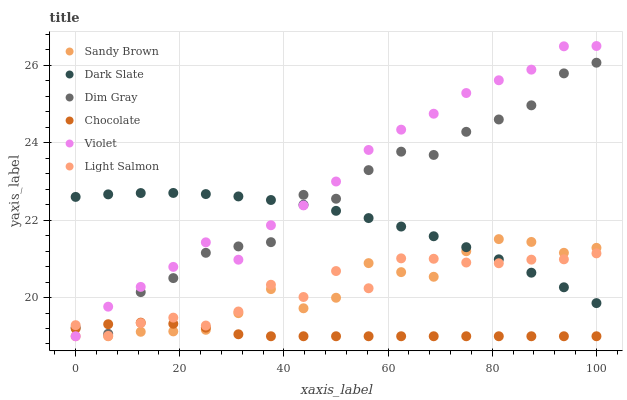Does Chocolate have the minimum area under the curve?
Answer yes or no. Yes. Does Violet have the maximum area under the curve?
Answer yes or no. Yes. Does Dim Gray have the minimum area under the curve?
Answer yes or no. No. Does Dim Gray have the maximum area under the curve?
Answer yes or no. No. Is Chocolate the smoothest?
Answer yes or no. Yes. Is Dim Gray the roughest?
Answer yes or no. Yes. Is Dim Gray the smoothest?
Answer yes or no. No. Is Chocolate the roughest?
Answer yes or no. No. Does Chocolate have the lowest value?
Answer yes or no. Yes. Does Dim Gray have the lowest value?
Answer yes or no. No. Does Violet have the highest value?
Answer yes or no. Yes. Does Dim Gray have the highest value?
Answer yes or no. No. Is Chocolate less than Dark Slate?
Answer yes or no. Yes. Is Dark Slate greater than Chocolate?
Answer yes or no. Yes. Does Dim Gray intersect Violet?
Answer yes or no. Yes. Is Dim Gray less than Violet?
Answer yes or no. No. Is Dim Gray greater than Violet?
Answer yes or no. No. Does Chocolate intersect Dark Slate?
Answer yes or no. No. 